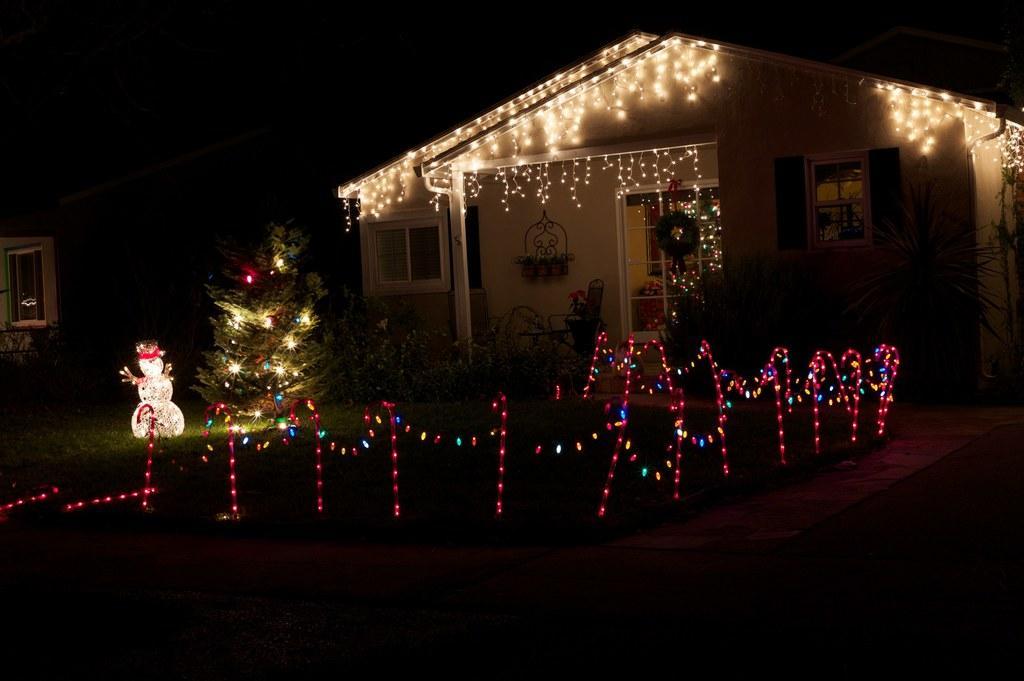Please provide a concise description of this image. In this image there is a house, there are lights, there are windows, there is a Christmas tree, there are lights on the Christmas tree, there are plants, there is the grass, there is a snowman on the grass, the background of the image is dark. 